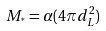Convert formula to latex. <formula><loc_0><loc_0><loc_500><loc_500>M _ { ^ { * } } = \alpha ( 4 \pi d _ { L } ^ { 2 } )</formula> 